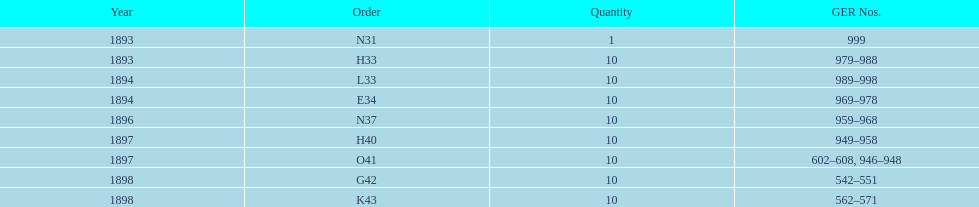What is the number of years with a quantity of 10? 5. 